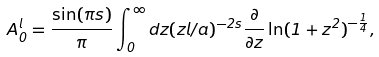Convert formula to latex. <formula><loc_0><loc_0><loc_500><loc_500>A _ { 0 } ^ { l } = { \frac { \sin ( \pi s ) } { \pi } } \int _ { 0 } ^ { \infty } d z ( z l / a ) ^ { - 2 s } { \frac { \partial } { \partial z } } \ln ( 1 + z ^ { 2 } ) ^ { - { \frac { 1 } { 4 } } } ,</formula> 